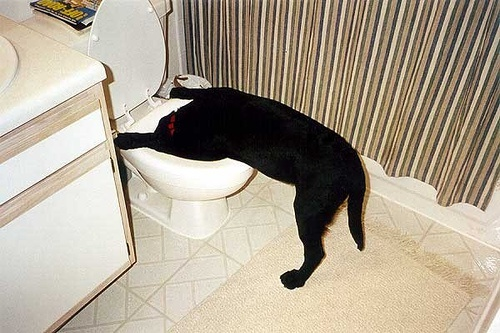Describe the objects in this image and their specific colors. I can see dog in darkgray, black, ivory, and maroon tones, toilet in darkgray, lightgray, and black tones, sink in darkgray, ivory, and tan tones, and book in darkgray, black, olive, and tan tones in this image. 